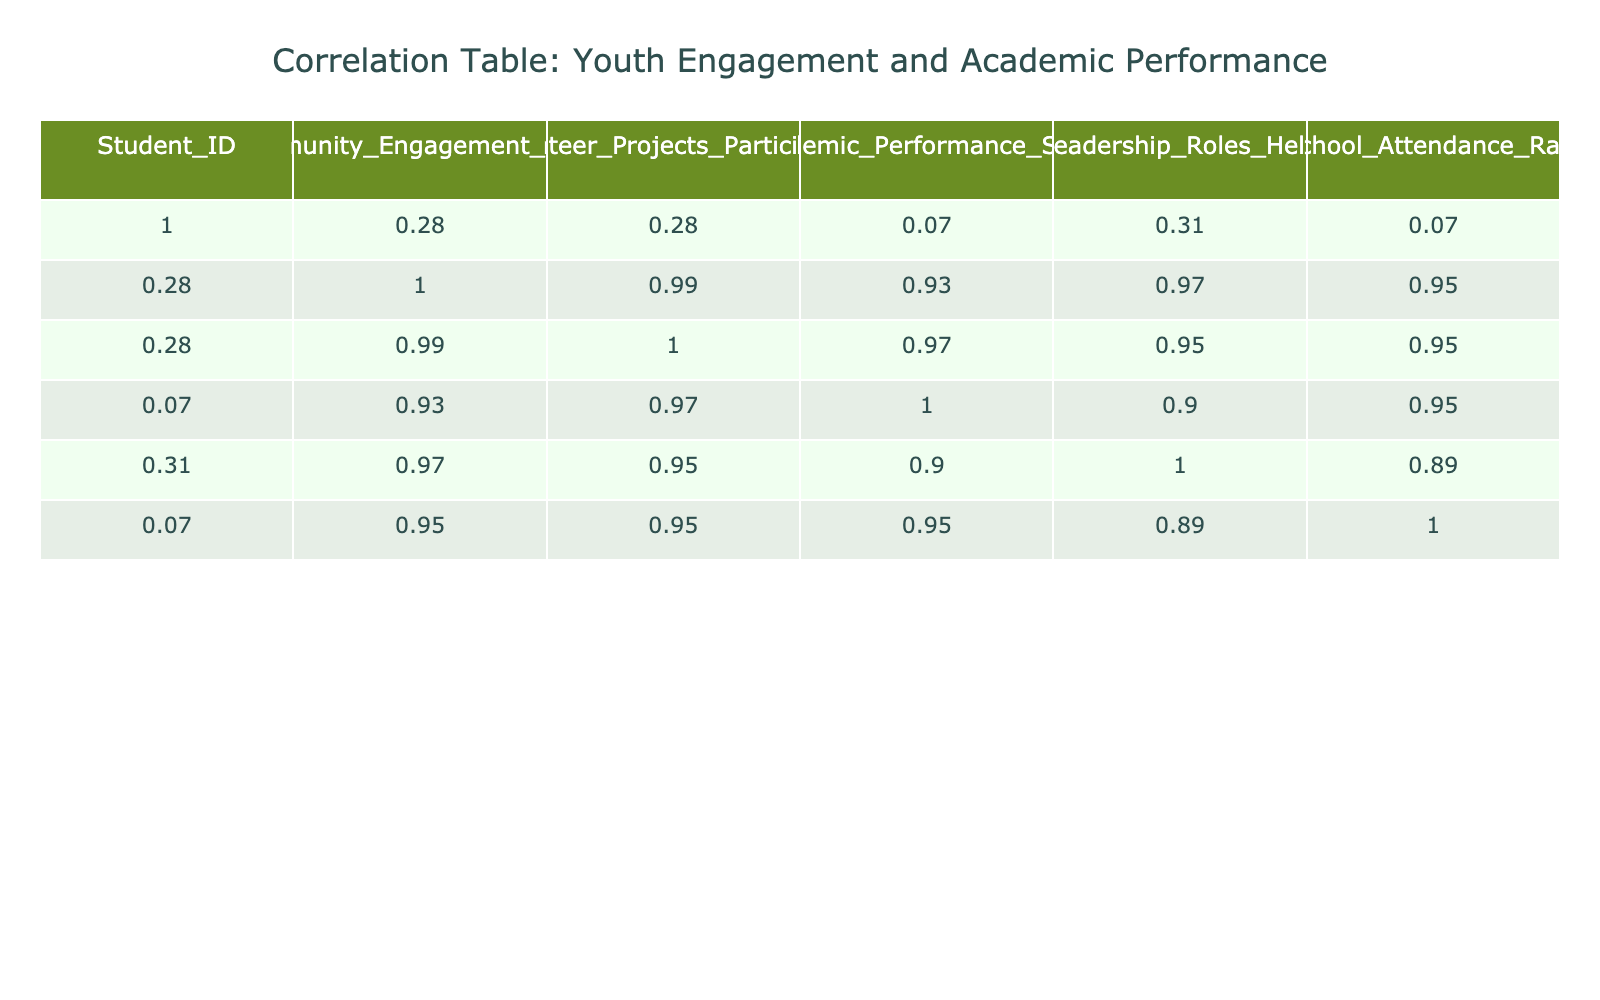What is the correlation between community engagement hours and academic performance score? Looking at the correlation table, the correlation value between Community Engagement Hours and Academic Performance Score is 0.93, indicating a strong positive correlation.
Answer: 0.93 What is the academic performance score of the student who participated in the highest number of volunteer projects? The student who participated in the highest number of volunteer projects (6 projects) is student 10, who has an academic performance score of 98.
Answer: 98 Is there a student with a perfect school attendance rate? Yes, student 10 has a perfect school attendance rate of 99%. This can be confirmed by examining the School Attendance Rate column.
Answer: Yes What is the average academic performance score for students who engaged in more than 15 community engagement hours? The students who engaged in more than 15 hours are students 3, 6, 8, and 10. Their scores are 92, 95, 89, and 98 respectively. The average score is (92 + 95 + 89 + 98) / 4 = 93.5.
Answer: 93.5 What is the difference in academic performance score between the student with the highest school attendance rate and the student with the lowest? The student with the highest attendance rate is student 10 with a score of 98, and the lowest attendance rate is student 4 with a score of 78. The difference is 98 - 78 = 20.
Answer: 20 What is the correlation between leadership roles held and academic performance score? The correlation value between Leadership Roles Held and Academic Performance Score is 0.74, indicating a moderate positive correlation.
Answer: 0.74 Is every student with more than three volunteer projects also engaged in at least 15 community engagement hours? No, student 5 has three volunteer projects but only engaged in 12 community engagement hours. This confirms not all students with more than three projects meet the engagement hours criterion.
Answer: No What is the sum of community engagement hours for students with an academic performance score above 90? The students with a score above 90 are students 3, 5, 6, 8, and 10. Their engagement hours are 20, 12, 25, 18, and 30 respectively. The sum is 20 + 12 + 25 + 18 + 30 = 105.
Answer: 105 